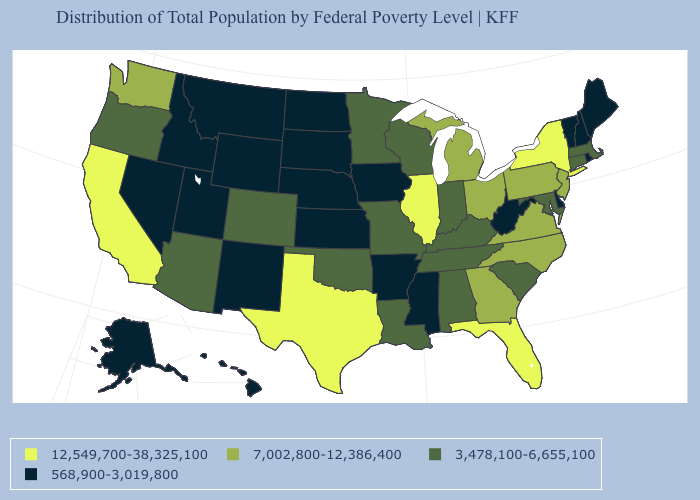What is the value of Virginia?
Quick response, please. 7,002,800-12,386,400. Which states hav the highest value in the MidWest?
Give a very brief answer. Illinois. What is the value of New York?
Concise answer only. 12,549,700-38,325,100. Name the states that have a value in the range 12,549,700-38,325,100?
Concise answer only. California, Florida, Illinois, New York, Texas. Name the states that have a value in the range 12,549,700-38,325,100?
Give a very brief answer. California, Florida, Illinois, New York, Texas. Among the states that border Wisconsin , which have the lowest value?
Concise answer only. Iowa. Does California have the lowest value in the USA?
Write a very short answer. No. Name the states that have a value in the range 568,900-3,019,800?
Write a very short answer. Alaska, Arkansas, Delaware, Hawaii, Idaho, Iowa, Kansas, Maine, Mississippi, Montana, Nebraska, Nevada, New Hampshire, New Mexico, North Dakota, Rhode Island, South Dakota, Utah, Vermont, West Virginia, Wyoming. What is the value of Connecticut?
Answer briefly. 3,478,100-6,655,100. Which states have the lowest value in the USA?
Short answer required. Alaska, Arkansas, Delaware, Hawaii, Idaho, Iowa, Kansas, Maine, Mississippi, Montana, Nebraska, Nevada, New Hampshire, New Mexico, North Dakota, Rhode Island, South Dakota, Utah, Vermont, West Virginia, Wyoming. Does Mississippi have the highest value in the South?
Quick response, please. No. Name the states that have a value in the range 7,002,800-12,386,400?
Answer briefly. Georgia, Michigan, New Jersey, North Carolina, Ohio, Pennsylvania, Virginia, Washington. Does California have the highest value in the West?
Be succinct. Yes. Name the states that have a value in the range 7,002,800-12,386,400?
Write a very short answer. Georgia, Michigan, New Jersey, North Carolina, Ohio, Pennsylvania, Virginia, Washington. Which states have the lowest value in the South?
Short answer required. Arkansas, Delaware, Mississippi, West Virginia. 